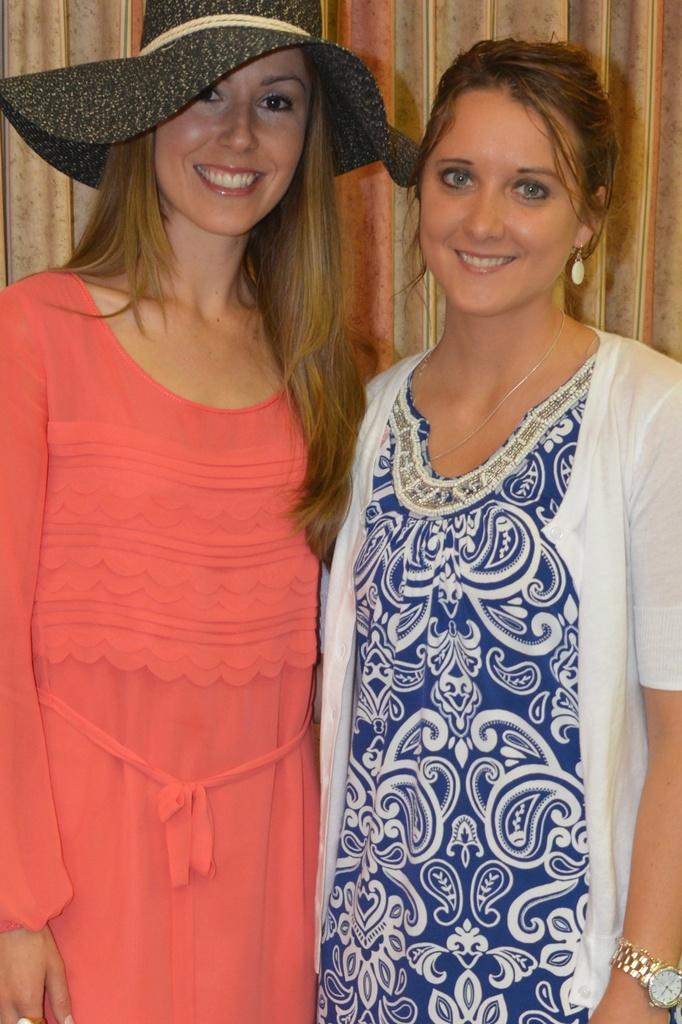How many people are in the image? There are two people in the image. What are the people doing in the image? The people are standing and smiling. What colors are featured in the people's dresses? The people are wearing orange, blue, and white dresses. What is the color of the background in the image? The background in the image is brown. Can you see a carriage in the image? No, there is no carriage present in the image. What type of crack is visible on the people's dresses? There are no cracks visible on the people's dresses; they appear to be in good condition. 